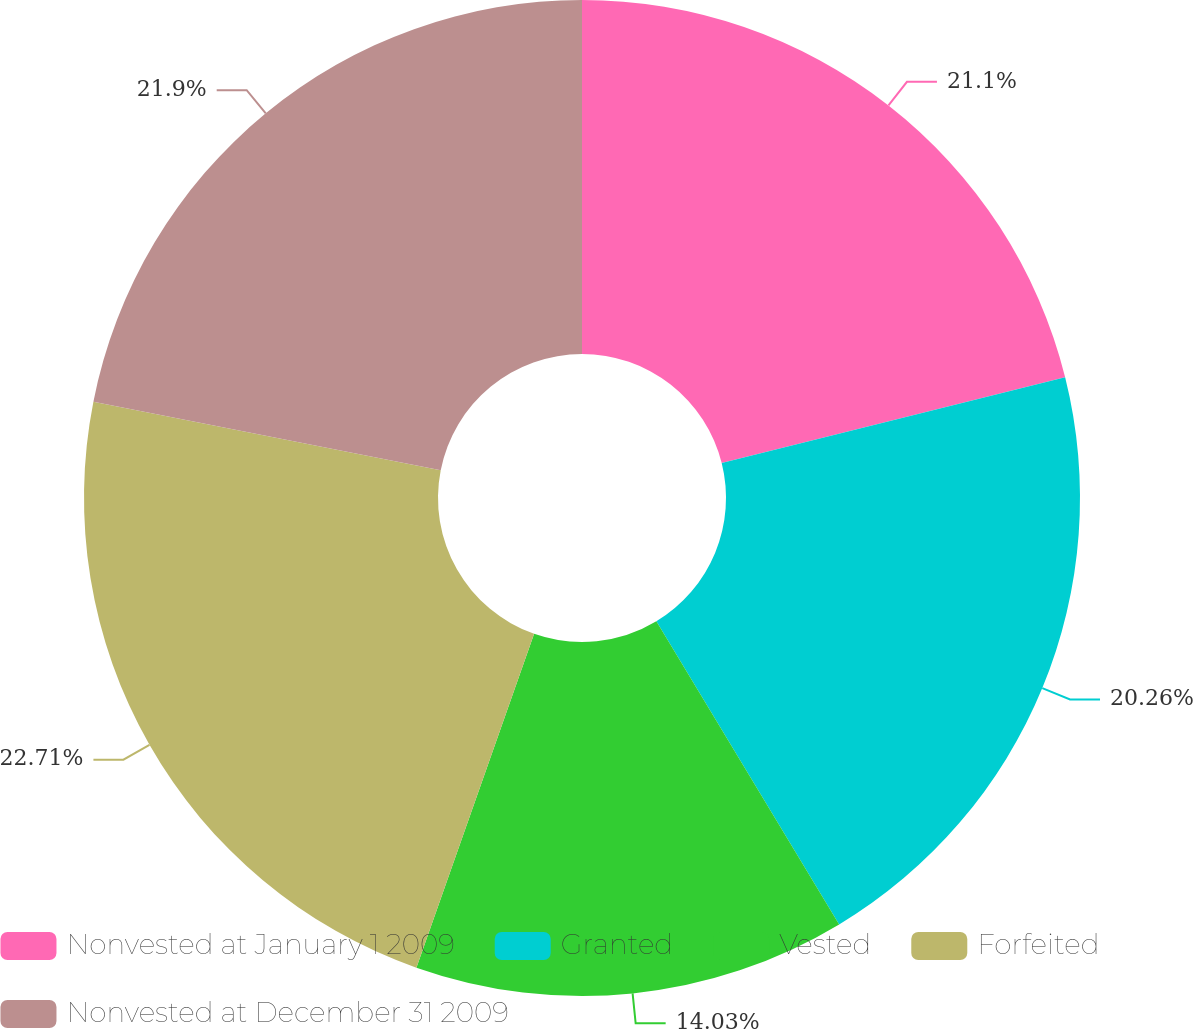<chart> <loc_0><loc_0><loc_500><loc_500><pie_chart><fcel>Nonvested at January 1 2009<fcel>Granted<fcel>Vested<fcel>Forfeited<fcel>Nonvested at December 31 2009<nl><fcel>21.1%<fcel>20.26%<fcel>14.03%<fcel>22.7%<fcel>21.9%<nl></chart> 